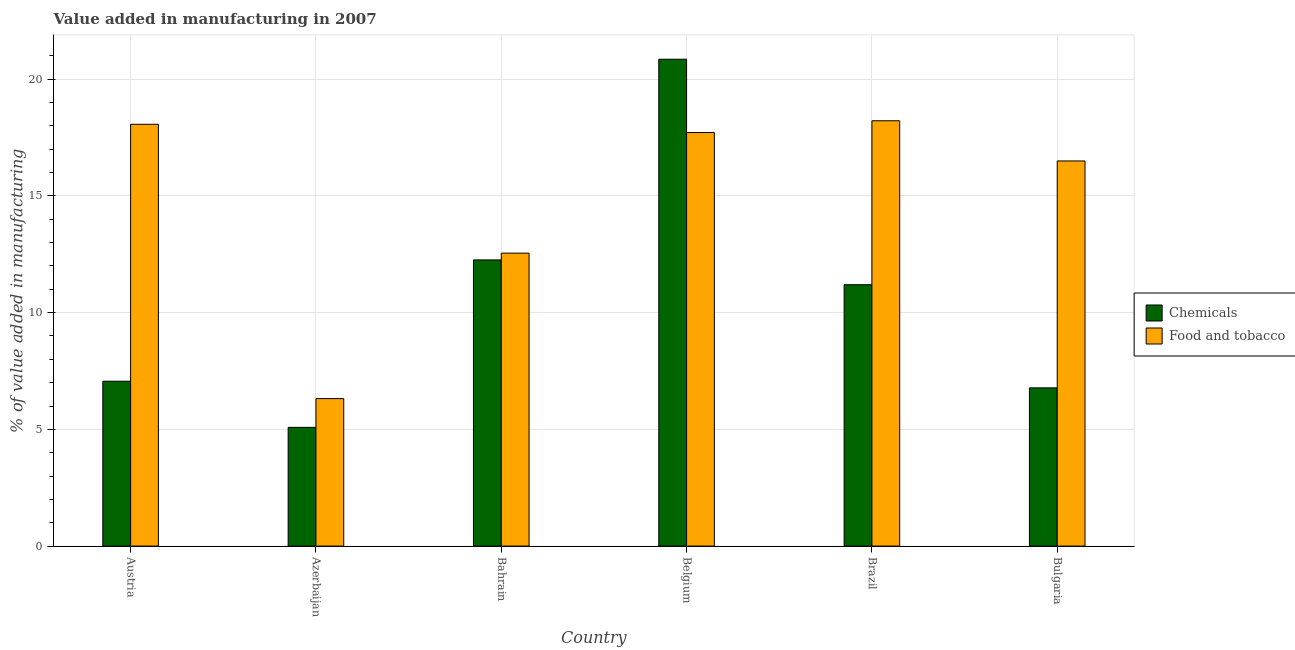Are the number of bars on each tick of the X-axis equal?
Keep it short and to the point. Yes. What is the label of the 2nd group of bars from the left?
Your response must be concise. Azerbaijan. What is the value added by  manufacturing chemicals in Bulgaria?
Your answer should be compact. 6.78. Across all countries, what is the maximum value added by manufacturing food and tobacco?
Keep it short and to the point. 18.22. Across all countries, what is the minimum value added by manufacturing food and tobacco?
Your answer should be very brief. 6.32. In which country was the value added by manufacturing food and tobacco minimum?
Provide a short and direct response. Azerbaijan. What is the total value added by manufacturing food and tobacco in the graph?
Provide a succinct answer. 89.37. What is the difference between the value added by  manufacturing chemicals in Bahrain and that in Belgium?
Keep it short and to the point. -8.6. What is the difference between the value added by manufacturing food and tobacco in Bulgaria and the value added by  manufacturing chemicals in Azerbaijan?
Provide a succinct answer. 11.41. What is the average value added by  manufacturing chemicals per country?
Your answer should be compact. 10.54. What is the difference between the value added by  manufacturing chemicals and value added by manufacturing food and tobacco in Brazil?
Make the answer very short. -7.02. In how many countries, is the value added by manufacturing food and tobacco greater than 2 %?
Keep it short and to the point. 6. What is the ratio of the value added by  manufacturing chemicals in Austria to that in Brazil?
Your response must be concise. 0.63. Is the difference between the value added by  manufacturing chemicals in Austria and Azerbaijan greater than the difference between the value added by manufacturing food and tobacco in Austria and Azerbaijan?
Make the answer very short. No. What is the difference between the highest and the second highest value added by  manufacturing chemicals?
Your response must be concise. 8.6. What is the difference between the highest and the lowest value added by  manufacturing chemicals?
Provide a short and direct response. 15.77. In how many countries, is the value added by  manufacturing chemicals greater than the average value added by  manufacturing chemicals taken over all countries?
Your answer should be very brief. 3. Is the sum of the value added by manufacturing food and tobacco in Austria and Belgium greater than the maximum value added by  manufacturing chemicals across all countries?
Offer a terse response. Yes. What does the 2nd bar from the left in Azerbaijan represents?
Your answer should be compact. Food and tobacco. What does the 2nd bar from the right in Belgium represents?
Provide a succinct answer. Chemicals. How many bars are there?
Make the answer very short. 12. What is the difference between two consecutive major ticks on the Y-axis?
Keep it short and to the point. 5. Does the graph contain any zero values?
Offer a very short reply. No. Does the graph contain grids?
Provide a succinct answer. Yes. How many legend labels are there?
Offer a very short reply. 2. How are the legend labels stacked?
Offer a terse response. Vertical. What is the title of the graph?
Keep it short and to the point. Value added in manufacturing in 2007. Does "Foreign Liabilities" appear as one of the legend labels in the graph?
Your answer should be very brief. No. What is the label or title of the X-axis?
Provide a succinct answer. Country. What is the label or title of the Y-axis?
Keep it short and to the point. % of value added in manufacturing. What is the % of value added in manufacturing in Chemicals in Austria?
Your response must be concise. 7.06. What is the % of value added in manufacturing of Food and tobacco in Austria?
Give a very brief answer. 18.07. What is the % of value added in manufacturing in Chemicals in Azerbaijan?
Keep it short and to the point. 5.09. What is the % of value added in manufacturing of Food and tobacco in Azerbaijan?
Provide a short and direct response. 6.32. What is the % of value added in manufacturing in Chemicals in Bahrain?
Offer a very short reply. 12.26. What is the % of value added in manufacturing in Food and tobacco in Bahrain?
Your response must be concise. 12.55. What is the % of value added in manufacturing in Chemicals in Belgium?
Keep it short and to the point. 20.86. What is the % of value added in manufacturing of Food and tobacco in Belgium?
Provide a short and direct response. 17.72. What is the % of value added in manufacturing in Chemicals in Brazil?
Keep it short and to the point. 11.2. What is the % of value added in manufacturing of Food and tobacco in Brazil?
Offer a very short reply. 18.22. What is the % of value added in manufacturing in Chemicals in Bulgaria?
Give a very brief answer. 6.78. What is the % of value added in manufacturing of Food and tobacco in Bulgaria?
Offer a terse response. 16.5. Across all countries, what is the maximum % of value added in manufacturing in Chemicals?
Provide a succinct answer. 20.86. Across all countries, what is the maximum % of value added in manufacturing in Food and tobacco?
Offer a very short reply. 18.22. Across all countries, what is the minimum % of value added in manufacturing in Chemicals?
Offer a very short reply. 5.09. Across all countries, what is the minimum % of value added in manufacturing in Food and tobacco?
Your answer should be compact. 6.32. What is the total % of value added in manufacturing in Chemicals in the graph?
Provide a succinct answer. 63.24. What is the total % of value added in manufacturing of Food and tobacco in the graph?
Your answer should be very brief. 89.37. What is the difference between the % of value added in manufacturing of Chemicals in Austria and that in Azerbaijan?
Make the answer very short. 1.98. What is the difference between the % of value added in manufacturing in Food and tobacco in Austria and that in Azerbaijan?
Provide a succinct answer. 11.75. What is the difference between the % of value added in manufacturing of Chemicals in Austria and that in Bahrain?
Offer a terse response. -5.2. What is the difference between the % of value added in manufacturing in Food and tobacco in Austria and that in Bahrain?
Offer a very short reply. 5.52. What is the difference between the % of value added in manufacturing of Chemicals in Austria and that in Belgium?
Offer a very short reply. -13.79. What is the difference between the % of value added in manufacturing in Food and tobacco in Austria and that in Belgium?
Your answer should be very brief. 0.35. What is the difference between the % of value added in manufacturing of Chemicals in Austria and that in Brazil?
Keep it short and to the point. -4.13. What is the difference between the % of value added in manufacturing of Food and tobacco in Austria and that in Brazil?
Ensure brevity in your answer.  -0.15. What is the difference between the % of value added in manufacturing of Chemicals in Austria and that in Bulgaria?
Your response must be concise. 0.29. What is the difference between the % of value added in manufacturing of Food and tobacco in Austria and that in Bulgaria?
Your answer should be very brief. 1.57. What is the difference between the % of value added in manufacturing in Chemicals in Azerbaijan and that in Bahrain?
Offer a very short reply. -7.17. What is the difference between the % of value added in manufacturing in Food and tobacco in Azerbaijan and that in Bahrain?
Your answer should be compact. -6.23. What is the difference between the % of value added in manufacturing of Chemicals in Azerbaijan and that in Belgium?
Offer a terse response. -15.77. What is the difference between the % of value added in manufacturing of Food and tobacco in Azerbaijan and that in Belgium?
Give a very brief answer. -11.4. What is the difference between the % of value added in manufacturing of Chemicals in Azerbaijan and that in Brazil?
Your response must be concise. -6.11. What is the difference between the % of value added in manufacturing of Food and tobacco in Azerbaijan and that in Brazil?
Give a very brief answer. -11.9. What is the difference between the % of value added in manufacturing of Chemicals in Azerbaijan and that in Bulgaria?
Keep it short and to the point. -1.69. What is the difference between the % of value added in manufacturing of Food and tobacco in Azerbaijan and that in Bulgaria?
Offer a terse response. -10.18. What is the difference between the % of value added in manufacturing of Chemicals in Bahrain and that in Belgium?
Your answer should be compact. -8.6. What is the difference between the % of value added in manufacturing of Food and tobacco in Bahrain and that in Belgium?
Give a very brief answer. -5.17. What is the difference between the % of value added in manufacturing of Chemicals in Bahrain and that in Brazil?
Offer a terse response. 1.06. What is the difference between the % of value added in manufacturing in Food and tobacco in Bahrain and that in Brazil?
Keep it short and to the point. -5.67. What is the difference between the % of value added in manufacturing in Chemicals in Bahrain and that in Bulgaria?
Ensure brevity in your answer.  5.48. What is the difference between the % of value added in manufacturing in Food and tobacco in Bahrain and that in Bulgaria?
Keep it short and to the point. -3.95. What is the difference between the % of value added in manufacturing in Chemicals in Belgium and that in Brazil?
Offer a terse response. 9.66. What is the difference between the % of value added in manufacturing in Food and tobacco in Belgium and that in Brazil?
Ensure brevity in your answer.  -0.5. What is the difference between the % of value added in manufacturing of Chemicals in Belgium and that in Bulgaria?
Provide a succinct answer. 14.08. What is the difference between the % of value added in manufacturing of Food and tobacco in Belgium and that in Bulgaria?
Offer a very short reply. 1.22. What is the difference between the % of value added in manufacturing in Chemicals in Brazil and that in Bulgaria?
Provide a succinct answer. 4.42. What is the difference between the % of value added in manufacturing in Food and tobacco in Brazil and that in Bulgaria?
Your response must be concise. 1.72. What is the difference between the % of value added in manufacturing of Chemicals in Austria and the % of value added in manufacturing of Food and tobacco in Azerbaijan?
Give a very brief answer. 0.74. What is the difference between the % of value added in manufacturing in Chemicals in Austria and the % of value added in manufacturing in Food and tobacco in Bahrain?
Provide a succinct answer. -5.49. What is the difference between the % of value added in manufacturing in Chemicals in Austria and the % of value added in manufacturing in Food and tobacco in Belgium?
Provide a succinct answer. -10.65. What is the difference between the % of value added in manufacturing of Chemicals in Austria and the % of value added in manufacturing of Food and tobacco in Brazil?
Your answer should be compact. -11.16. What is the difference between the % of value added in manufacturing of Chemicals in Austria and the % of value added in manufacturing of Food and tobacco in Bulgaria?
Make the answer very short. -9.43. What is the difference between the % of value added in manufacturing of Chemicals in Azerbaijan and the % of value added in manufacturing of Food and tobacco in Bahrain?
Offer a terse response. -7.46. What is the difference between the % of value added in manufacturing in Chemicals in Azerbaijan and the % of value added in manufacturing in Food and tobacco in Belgium?
Give a very brief answer. -12.63. What is the difference between the % of value added in manufacturing in Chemicals in Azerbaijan and the % of value added in manufacturing in Food and tobacco in Brazil?
Offer a very short reply. -13.13. What is the difference between the % of value added in manufacturing in Chemicals in Azerbaijan and the % of value added in manufacturing in Food and tobacco in Bulgaria?
Give a very brief answer. -11.41. What is the difference between the % of value added in manufacturing of Chemicals in Bahrain and the % of value added in manufacturing of Food and tobacco in Belgium?
Offer a terse response. -5.46. What is the difference between the % of value added in manufacturing of Chemicals in Bahrain and the % of value added in manufacturing of Food and tobacco in Brazil?
Your answer should be compact. -5.96. What is the difference between the % of value added in manufacturing in Chemicals in Bahrain and the % of value added in manufacturing in Food and tobacco in Bulgaria?
Your answer should be compact. -4.24. What is the difference between the % of value added in manufacturing of Chemicals in Belgium and the % of value added in manufacturing of Food and tobacco in Brazil?
Your answer should be very brief. 2.64. What is the difference between the % of value added in manufacturing in Chemicals in Belgium and the % of value added in manufacturing in Food and tobacco in Bulgaria?
Offer a terse response. 4.36. What is the difference between the % of value added in manufacturing in Chemicals in Brazil and the % of value added in manufacturing in Food and tobacco in Bulgaria?
Provide a short and direct response. -5.3. What is the average % of value added in manufacturing in Chemicals per country?
Ensure brevity in your answer.  10.54. What is the average % of value added in manufacturing of Food and tobacco per country?
Offer a very short reply. 14.89. What is the difference between the % of value added in manufacturing in Chemicals and % of value added in manufacturing in Food and tobacco in Austria?
Provide a short and direct response. -11.01. What is the difference between the % of value added in manufacturing of Chemicals and % of value added in manufacturing of Food and tobacco in Azerbaijan?
Ensure brevity in your answer.  -1.23. What is the difference between the % of value added in manufacturing in Chemicals and % of value added in manufacturing in Food and tobacco in Bahrain?
Your answer should be compact. -0.29. What is the difference between the % of value added in manufacturing in Chemicals and % of value added in manufacturing in Food and tobacco in Belgium?
Your answer should be very brief. 3.14. What is the difference between the % of value added in manufacturing of Chemicals and % of value added in manufacturing of Food and tobacco in Brazil?
Your response must be concise. -7.02. What is the difference between the % of value added in manufacturing of Chemicals and % of value added in manufacturing of Food and tobacco in Bulgaria?
Your answer should be very brief. -9.72. What is the ratio of the % of value added in manufacturing in Chemicals in Austria to that in Azerbaijan?
Give a very brief answer. 1.39. What is the ratio of the % of value added in manufacturing in Food and tobacco in Austria to that in Azerbaijan?
Your answer should be compact. 2.86. What is the ratio of the % of value added in manufacturing in Chemicals in Austria to that in Bahrain?
Make the answer very short. 0.58. What is the ratio of the % of value added in manufacturing in Food and tobacco in Austria to that in Bahrain?
Offer a terse response. 1.44. What is the ratio of the % of value added in manufacturing of Chemicals in Austria to that in Belgium?
Keep it short and to the point. 0.34. What is the ratio of the % of value added in manufacturing of Food and tobacco in Austria to that in Belgium?
Your answer should be compact. 1.02. What is the ratio of the % of value added in manufacturing in Chemicals in Austria to that in Brazil?
Offer a terse response. 0.63. What is the ratio of the % of value added in manufacturing of Food and tobacco in Austria to that in Brazil?
Your answer should be compact. 0.99. What is the ratio of the % of value added in manufacturing in Chemicals in Austria to that in Bulgaria?
Provide a short and direct response. 1.04. What is the ratio of the % of value added in manufacturing in Food and tobacco in Austria to that in Bulgaria?
Offer a very short reply. 1.1. What is the ratio of the % of value added in manufacturing in Chemicals in Azerbaijan to that in Bahrain?
Provide a short and direct response. 0.41. What is the ratio of the % of value added in manufacturing of Food and tobacco in Azerbaijan to that in Bahrain?
Provide a short and direct response. 0.5. What is the ratio of the % of value added in manufacturing of Chemicals in Azerbaijan to that in Belgium?
Provide a short and direct response. 0.24. What is the ratio of the % of value added in manufacturing in Food and tobacco in Azerbaijan to that in Belgium?
Offer a very short reply. 0.36. What is the ratio of the % of value added in manufacturing in Chemicals in Azerbaijan to that in Brazil?
Ensure brevity in your answer.  0.45. What is the ratio of the % of value added in manufacturing of Food and tobacco in Azerbaijan to that in Brazil?
Your response must be concise. 0.35. What is the ratio of the % of value added in manufacturing of Chemicals in Azerbaijan to that in Bulgaria?
Keep it short and to the point. 0.75. What is the ratio of the % of value added in manufacturing in Food and tobacco in Azerbaijan to that in Bulgaria?
Ensure brevity in your answer.  0.38. What is the ratio of the % of value added in manufacturing of Chemicals in Bahrain to that in Belgium?
Offer a terse response. 0.59. What is the ratio of the % of value added in manufacturing in Food and tobacco in Bahrain to that in Belgium?
Your response must be concise. 0.71. What is the ratio of the % of value added in manufacturing in Chemicals in Bahrain to that in Brazil?
Ensure brevity in your answer.  1.09. What is the ratio of the % of value added in manufacturing in Food and tobacco in Bahrain to that in Brazil?
Offer a terse response. 0.69. What is the ratio of the % of value added in manufacturing of Chemicals in Bahrain to that in Bulgaria?
Ensure brevity in your answer.  1.81. What is the ratio of the % of value added in manufacturing in Food and tobacco in Bahrain to that in Bulgaria?
Give a very brief answer. 0.76. What is the ratio of the % of value added in manufacturing in Chemicals in Belgium to that in Brazil?
Offer a terse response. 1.86. What is the ratio of the % of value added in manufacturing of Food and tobacco in Belgium to that in Brazil?
Offer a very short reply. 0.97. What is the ratio of the % of value added in manufacturing of Chemicals in Belgium to that in Bulgaria?
Your response must be concise. 3.08. What is the ratio of the % of value added in manufacturing in Food and tobacco in Belgium to that in Bulgaria?
Your answer should be compact. 1.07. What is the ratio of the % of value added in manufacturing of Chemicals in Brazil to that in Bulgaria?
Offer a very short reply. 1.65. What is the ratio of the % of value added in manufacturing of Food and tobacco in Brazil to that in Bulgaria?
Your response must be concise. 1.1. What is the difference between the highest and the second highest % of value added in manufacturing of Chemicals?
Offer a terse response. 8.6. What is the difference between the highest and the second highest % of value added in manufacturing of Food and tobacco?
Offer a terse response. 0.15. What is the difference between the highest and the lowest % of value added in manufacturing in Chemicals?
Give a very brief answer. 15.77. What is the difference between the highest and the lowest % of value added in manufacturing in Food and tobacco?
Give a very brief answer. 11.9. 